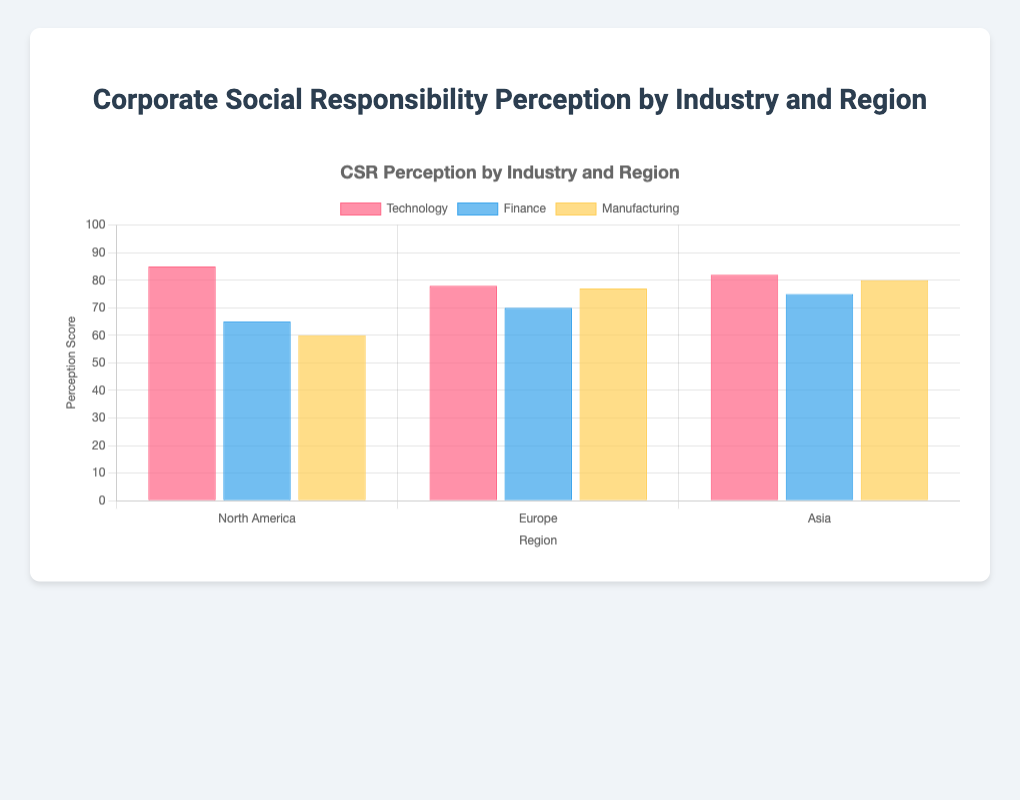What is the average perception score for Technology companies across all regions? To find the average, sum the perception scores for Technology companies and then divide by the number of Technology companies: (85 + 78 + 82 + 88 + 79) / 5 = 412 / 5 = 82.4
Answer: 82.4 Which region has the highest overall perception score for all industries combined? Sum the perception scores for all industries in each region and compare: North America (85 + 65 + 60 + 88 + 62 = 360), Europe (78 + 70 + 77 + 68 + 75 = 368), Asia (82 + 75 + 80 + 72 + 79 = 388). Asia has the highest score with 388.
Answer: Asia Among the Manufacturing companies, which company has the lowest perception score and what is the score? Compare the perception scores of General Motors (60), Siemens (77), Toyota (80), Boeing (62), Rolls-Royce (75). The lowest is General Motors with a score of 60.
Answer: General Motors, 60 Which color represents the Finance industry in the grouped bar chart? The snippet indicates three colors: red, blue, and yellow. Reviewing the datasets' order, the second color (blue) corresponds to Finance.
Answer: Blue What is the difference in perception scores between the highest and lowest scoring companies within the Finance industry? Identify the highest and lowest scores: HSBC (75), Goldman Sachs (65). Difference: 75 - 65 = 10.
Answer: 10 How does the perception score of Apple (Technology) compare to Deutsche Bank (Finance)? Apple's score is 88 and Deutsche Bank's is 70. By comparing, Apple has a higher score.
Answer: Apple has a higher score What is the combined perception score of all regions for manufacturing companies? Sum of all manufacturing company scores: General Motors (60), Siemens (77), Toyota (80), Boeing (62), Rolls-Royce (75) = 60 + 77 + 80 + 62 + 75 = 354.
Answer: 354 Which industry has the highest average perception score across all regions? Calculate the average for each industry: Technology (82.4), Finance (68.3), Manufacturing (70.8). Technology has the highest average.
Answer: Technology In which region does the Technology industry have the lowest perception score? Compare Technology's scores by region: North America (85, 88), Europe (78), Asia (82, 79). The lowest region is Europe with a score of 78.
Answer: Europe What is the perception score difference between Samsung and Tencent, and which has the higher score? Samsung has a score of 82, Tencent has 79. Difference: 82 - 79 = 3. Samsung has the higher score.
Answer: 3, Samsung 